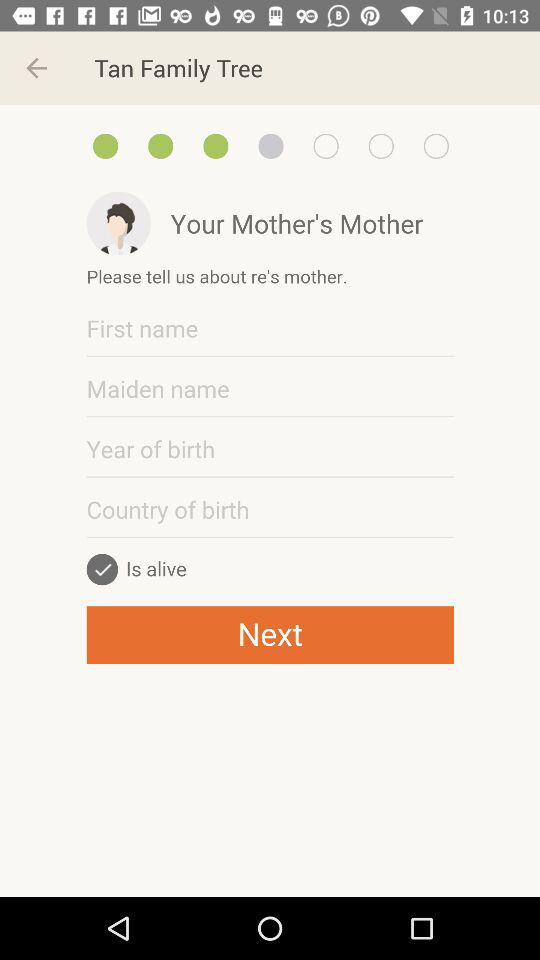Where was Grandmother Tan born?
When the provided information is insufficient, respond with <no answer>. <no answer> 